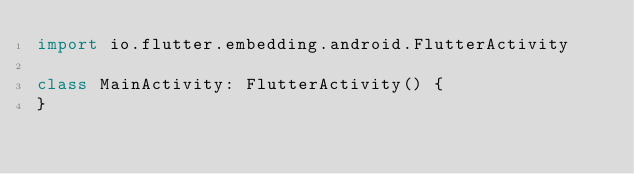<code> <loc_0><loc_0><loc_500><loc_500><_Kotlin_>import io.flutter.embedding.android.FlutterActivity

class MainActivity: FlutterActivity() {
}
</code> 